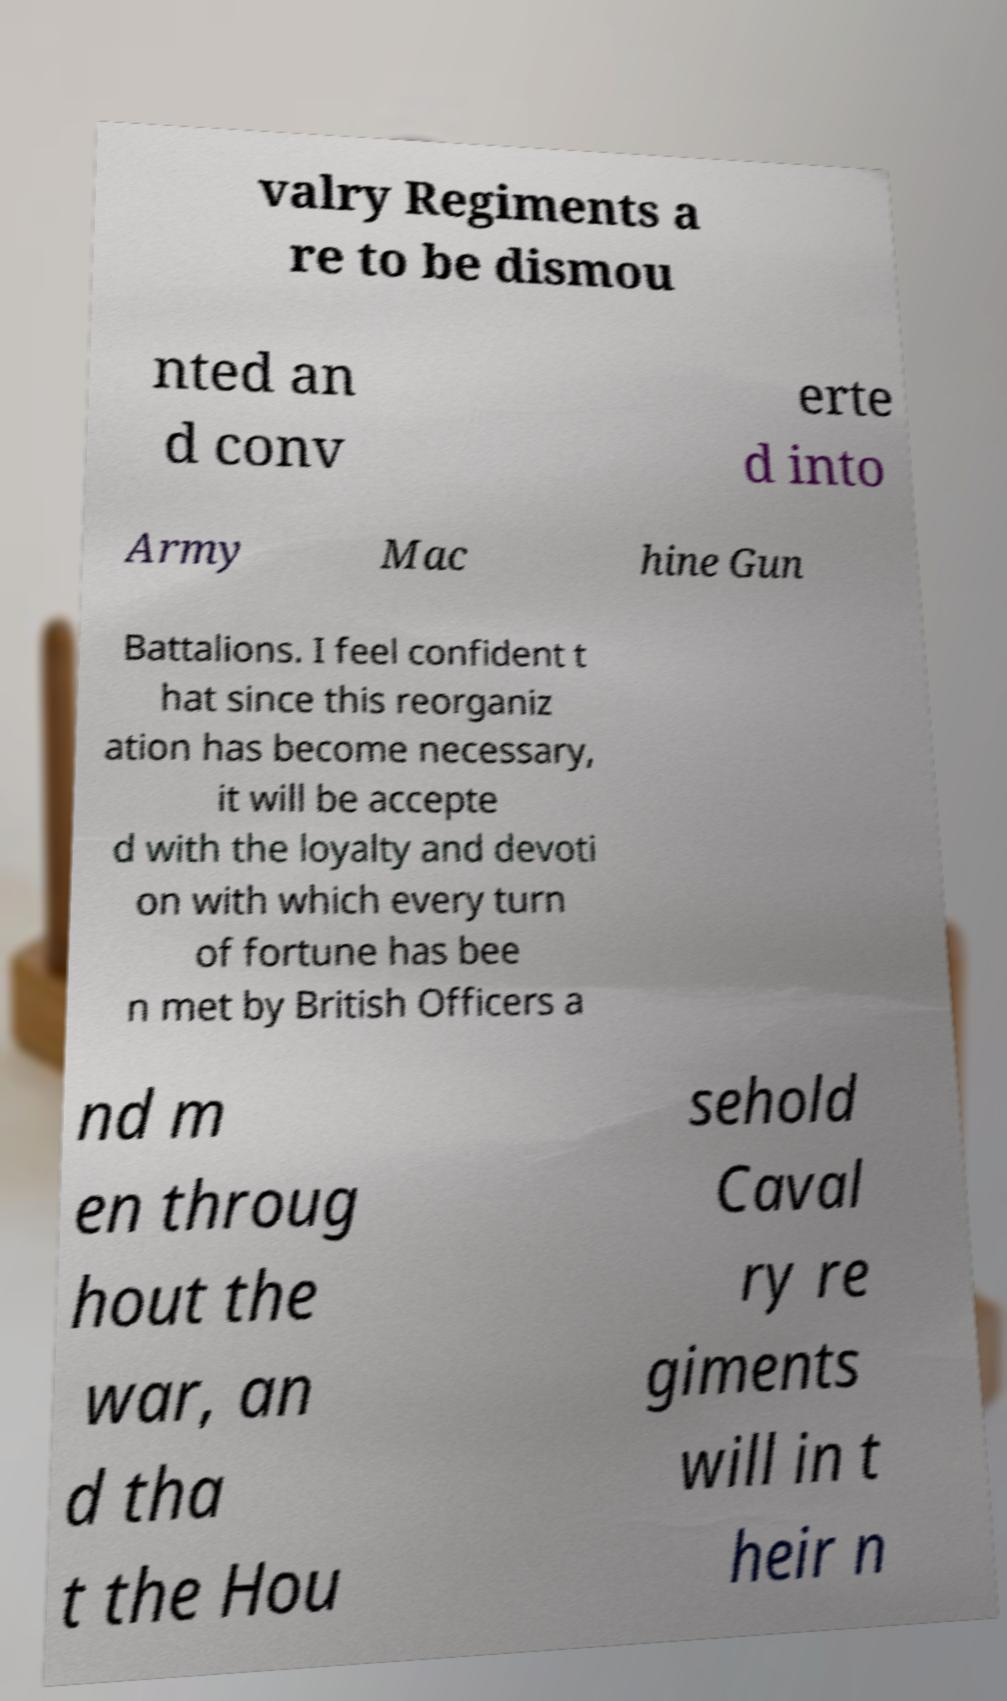What messages or text are displayed in this image? I need them in a readable, typed format. valry Regiments a re to be dismou nted an d conv erte d into Army Mac hine Gun Battalions. I feel confident t hat since this reorganiz ation has become necessary, it will be accepte d with the loyalty and devoti on with which every turn of fortune has bee n met by British Officers a nd m en throug hout the war, an d tha t the Hou sehold Caval ry re giments will in t heir n 